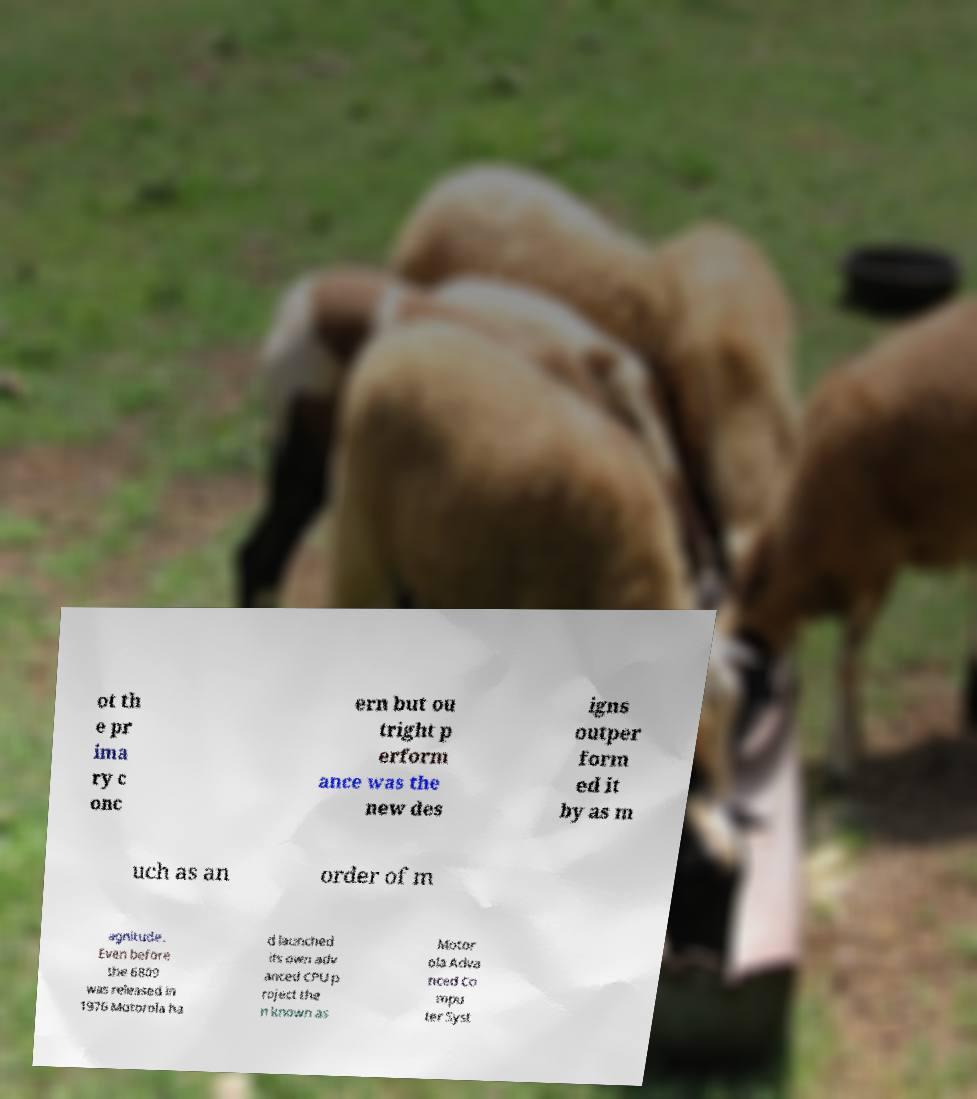What messages or text are displayed in this image? I need them in a readable, typed format. ot th e pr ima ry c onc ern but ou tright p erform ance was the new des igns outper form ed it by as m uch as an order of m agnitude. Even before the 6809 was released in 1976 Motorola ha d launched its own adv anced CPU p roject the n known as Motor ola Adva nced Co mpu ter Syst 